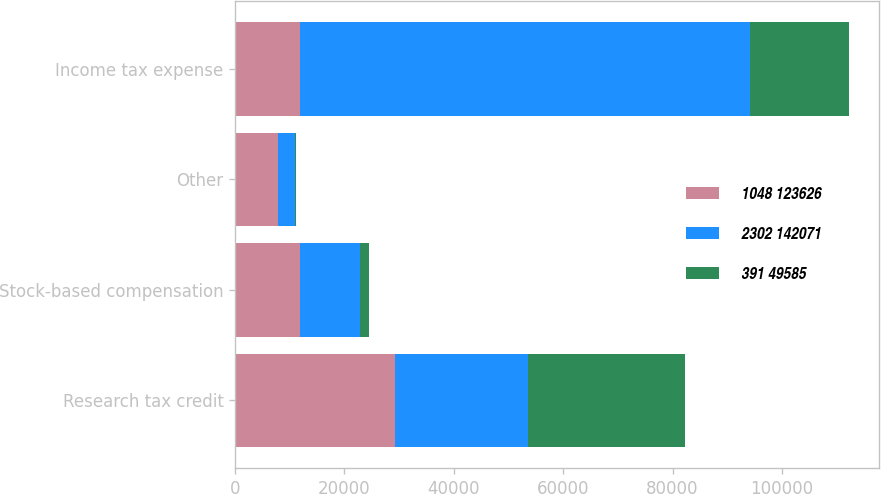Convert chart to OTSL. <chart><loc_0><loc_0><loc_500><loc_500><stacked_bar_chart><ecel><fcel>Research tax credit<fcel>Stock-based compensation<fcel>Other<fcel>Income tax expense<nl><fcel>1048 123626<fcel>29294<fcel>11876<fcel>7785<fcel>11876<nl><fcel>2302 142071<fcel>24270<fcel>10983<fcel>3173<fcel>82306<nl><fcel>391 49585<fcel>28729<fcel>1668<fcel>151<fcel>18023<nl></chart> 